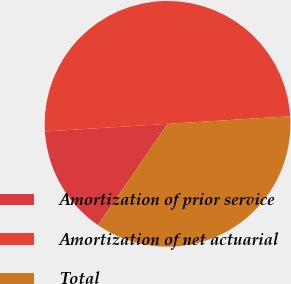Convert chart. <chart><loc_0><loc_0><loc_500><loc_500><pie_chart><fcel>Amortization of prior service<fcel>Amortization of net actuarial<fcel>Total<nl><fcel>14.43%<fcel>50.0%<fcel>35.57%<nl></chart> 